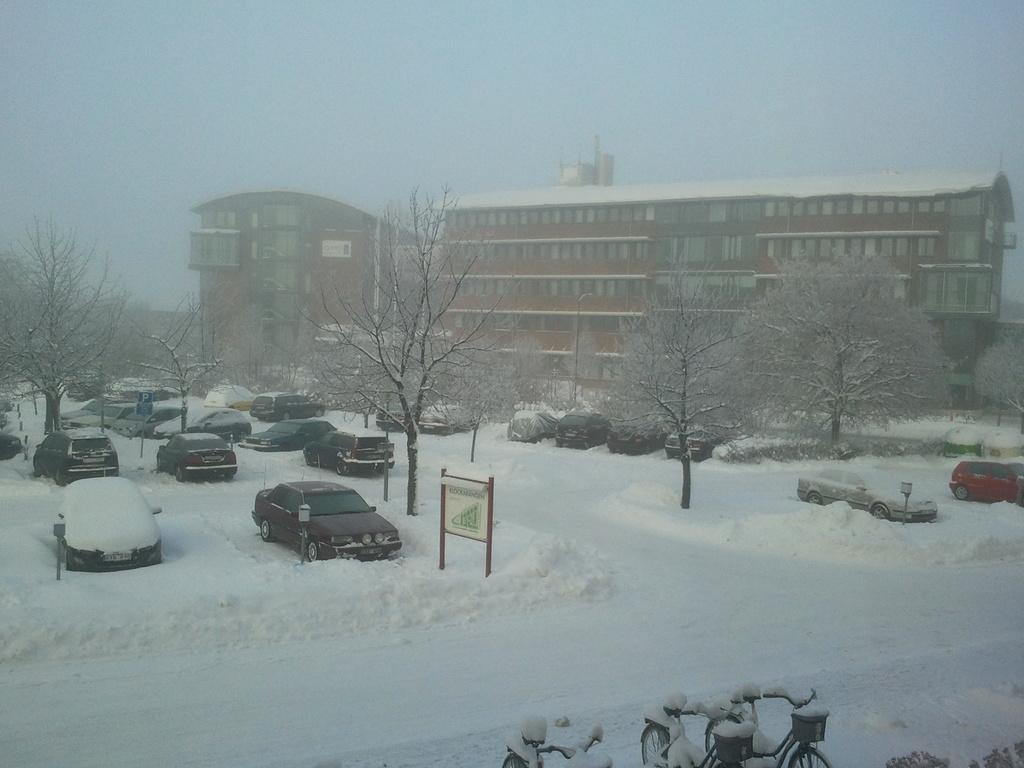What is the condition of the land in the image? The land in the image is covered in snow. What type of structures can be seen in the image? There are buildings in the image. What natural elements are present in the image? Trees are present in the image. What type of vehicles are visible in the image? Cars are visible in the image. Where are the bicycles located in the image? Bicycles are located at the bottom of the image. What type of ghost can be seen interacting with the snow in the image? There are no ghosts present in the image; it features snow-covered land, buildings, trees, cars, and bicycles. What shape is the cream forming in the image? There is no cream present in the image. 